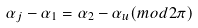Convert formula to latex. <formula><loc_0><loc_0><loc_500><loc_500>\alpha _ { j } - \alpha _ { 1 } = \alpha _ { 2 } - \alpha _ { u } ( m o d 2 \pi )</formula> 